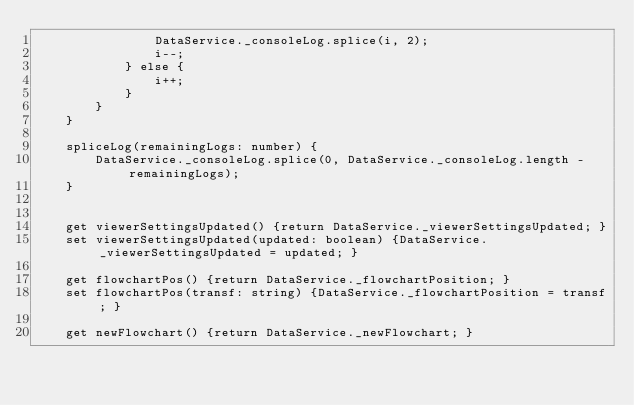Convert code to text. <code><loc_0><loc_0><loc_500><loc_500><_TypeScript_>                DataService._consoleLog.splice(i, 2);
                i--;
            } else {
                i++;
            }
        }
    }

    spliceLog(remainingLogs: number) {
        DataService._consoleLog.splice(0, DataService._consoleLog.length - remainingLogs);
    }


    get viewerSettingsUpdated() {return DataService._viewerSettingsUpdated; }
    set viewerSettingsUpdated(updated: boolean) {DataService._viewerSettingsUpdated = updated; }

    get flowchartPos() {return DataService._flowchartPosition; }
    set flowchartPos(transf: string) {DataService._flowchartPosition = transf; }

    get newFlowchart() {return DataService._newFlowchart; }</code> 